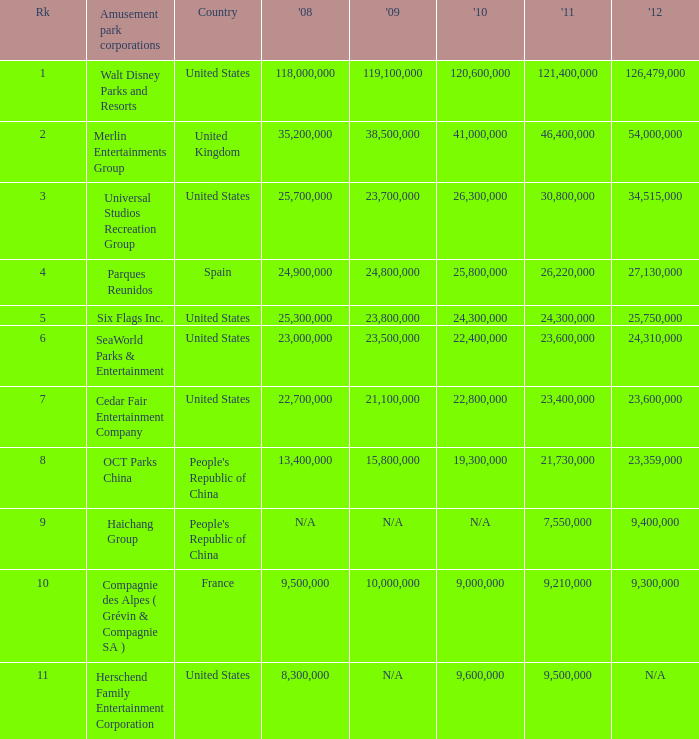In the United States the 2011 attendance at this amusement park corporation was larger than 30,800,000 but lists what as its 2008 attendance? 118000000.0. 